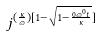Convert formula to latex. <formula><loc_0><loc_0><loc_500><loc_500>j ^ { ( \frac { \kappa } { \varpi } ) [ 1 - \sqrt { 1 - \frac { 0 \varpi ^ { 0 } t } { \kappa } } ] }</formula> 